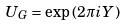Convert formula to latex. <formula><loc_0><loc_0><loc_500><loc_500>U _ { G } = \exp \left ( 2 \pi i { Y } \right )</formula> 